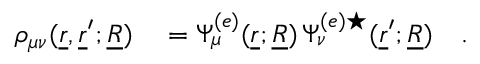Convert formula to latex. <formula><loc_0><loc_0><loc_500><loc_500>\begin{array} { r l } { \rho _ { \mu \nu } ( \underline { r } , \underline { r } ^ { \prime } ; \underline { R } ) } & = \Psi _ { \mu } ^ { ( e ) } ( \underline { r } ; \underline { R } ) \, \Psi _ { \nu } ^ { ( e ) ^ { * } } ( \underline { r } ^ { \prime } ; \underline { R } ) \quad . } \end{array}</formula> 